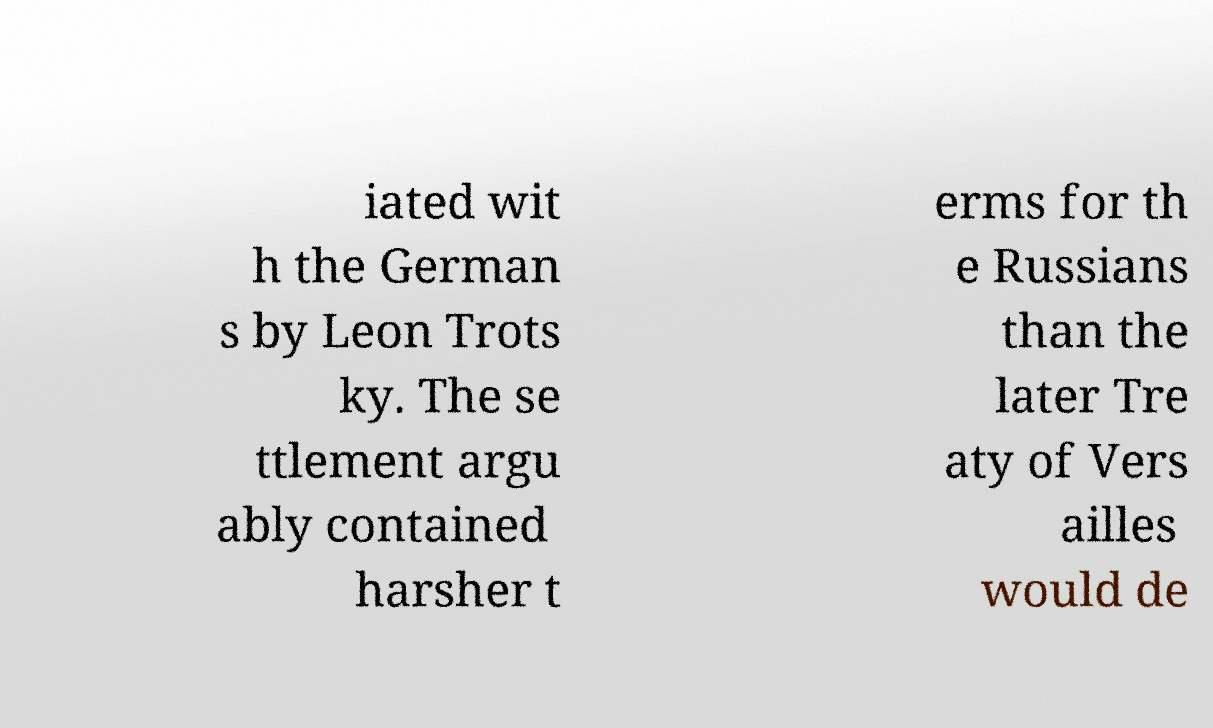Could you extract and type out the text from this image? iated wit h the German s by Leon Trots ky. The se ttlement argu ably contained harsher t erms for th e Russians than the later Tre aty of Vers ailles would de 